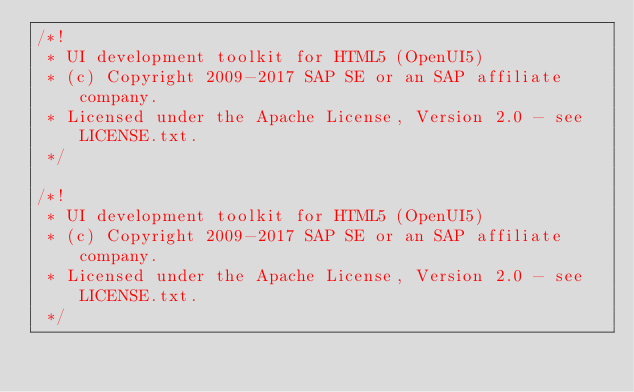<code> <loc_0><loc_0><loc_500><loc_500><_CSS_>/*!
 * UI development toolkit for HTML5 (OpenUI5)
 * (c) Copyright 2009-2017 SAP SE or an SAP affiliate company.
 * Licensed under the Apache License, Version 2.0 - see LICENSE.txt.
 */
 
/*!
 * UI development toolkit for HTML5 (OpenUI5)
 * (c) Copyright 2009-2017 SAP SE or an SAP affiliate company.
 * Licensed under the Apache License, Version 2.0 - see LICENSE.txt.
 */</code> 